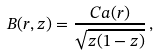Convert formula to latex. <formula><loc_0><loc_0><loc_500><loc_500>B ( r , z ) = \frac { C a ( r ) } { \sqrt { z ( 1 - z ) } } \, ,</formula> 